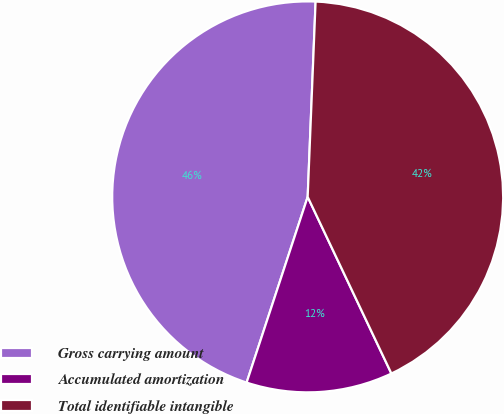<chart> <loc_0><loc_0><loc_500><loc_500><pie_chart><fcel>Gross carrying amount<fcel>Accumulated amortization<fcel>Total identifiable intangible<nl><fcel>45.59%<fcel>12.1%<fcel>42.31%<nl></chart> 